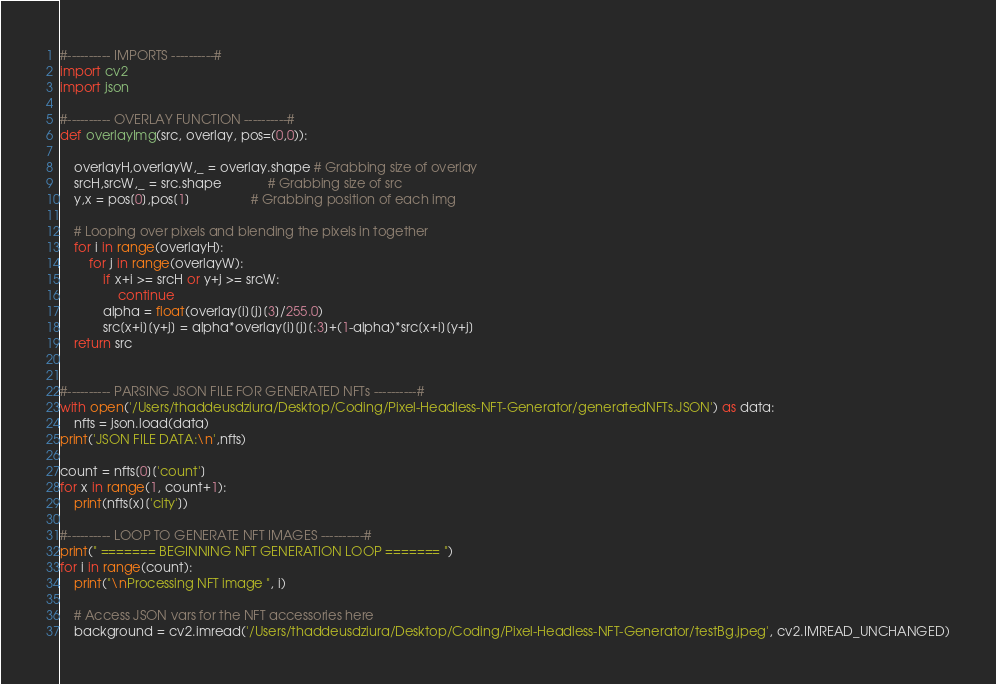Convert code to text. <code><loc_0><loc_0><loc_500><loc_500><_Python_>
#---------- IMPORTS ----------#
import cv2
import json

#---------- OVERLAY FUNCTION ----------#
def overlayImg(src, overlay, pos=(0,0)):

    overlayH,overlayW,_ = overlay.shape # Grabbing size of overlay
    srcH,srcW,_ = src.shape             # Grabbing size of src
    y,x = pos[0],pos[1]                 # Grabbing position of each img

    # Looping over pixels and blending the pixels in together
    for i in range(overlayH):
        for j in range(overlayW):
            if x+i >= srcH or y+j >= srcW:
                continue
            alpha = float(overlay[i][j][3]/255.0)
            src[x+i][y+j] = alpha*overlay[i][j][:3]+(1-alpha)*src[x+i][y+j]
    return src


#---------- PARSING JSON FILE FOR GENERATED NFTs ----------#
with open('/Users/thaddeusdziura/Desktop/Coding/Pixel-Headless-NFT-Generator/generatedNFTs.JSON') as data:
    nfts = json.load(data)
print('JSON FILE DATA:\n',nfts)

count = nfts[0]['count']
for x in range(1, count+1):
    print(nfts[x]['city'])

#---------- LOOP TO GENERATE NFT IMAGES ----------#
print(" ======= BEGINNING NFT GENERATION LOOP ======= ")
for i in range(count):
    print("\nProcessing NFT image ", i)

    # Access JSON vars for the NFT accessories here
    background = cv2.imread('/Users/thaddeusdziura/Desktop/Coding/Pixel-Headless-NFT-Generator/testBg.jpeg', cv2.IMREAD_UNCHANGED)</code> 